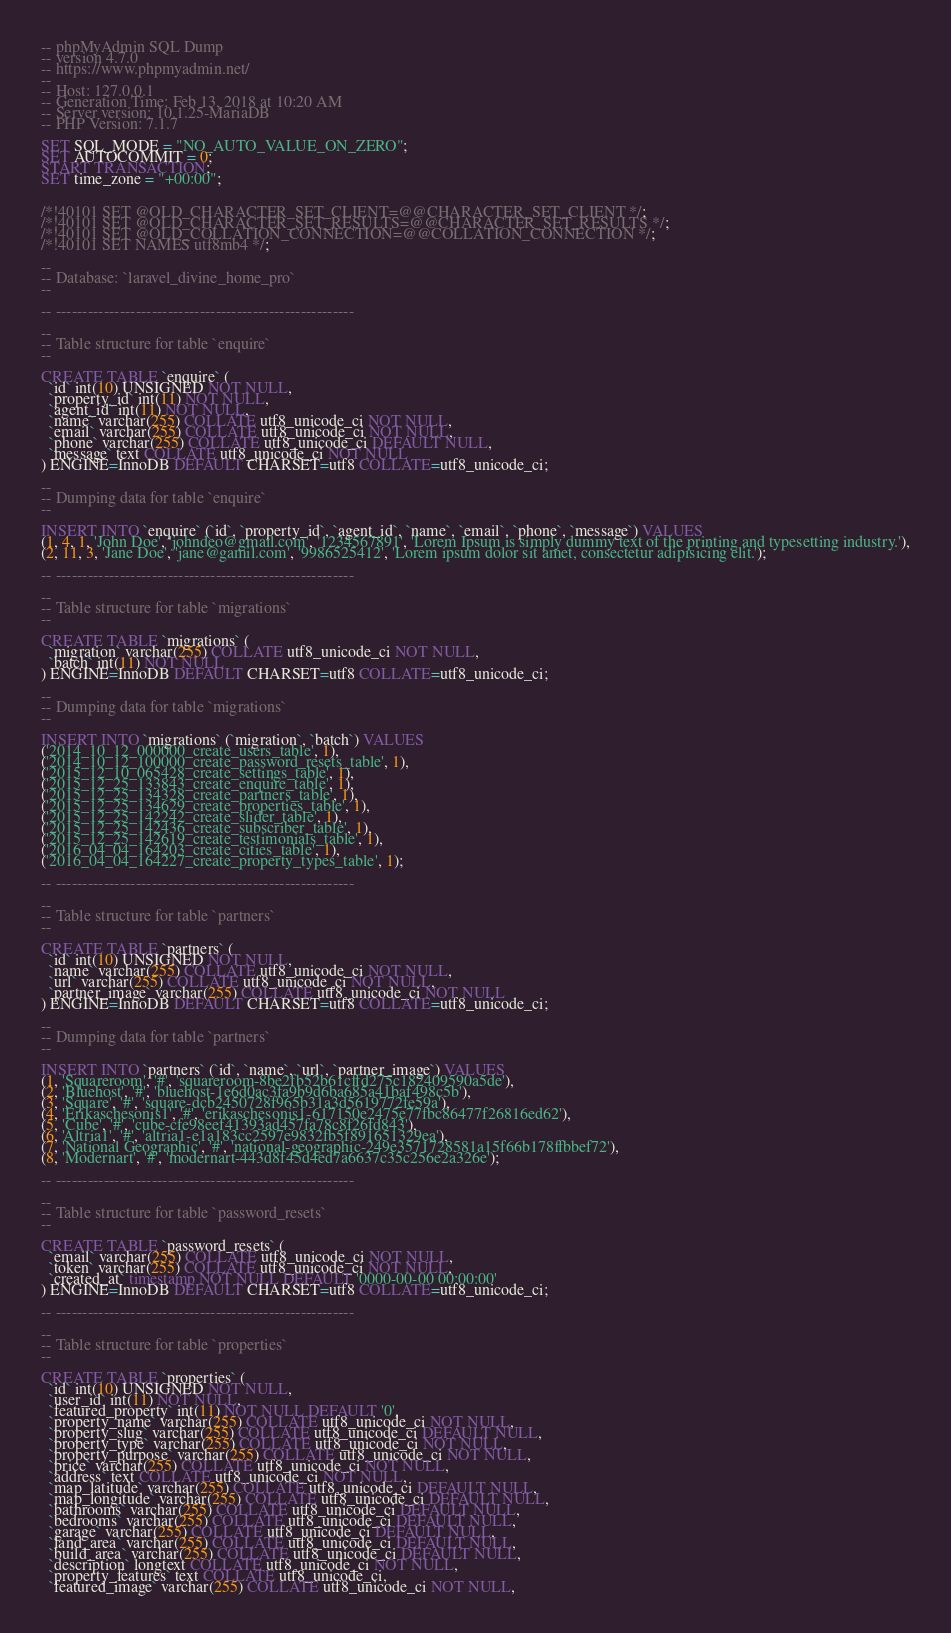<code> <loc_0><loc_0><loc_500><loc_500><_SQL_>-- phpMyAdmin SQL Dump
-- version 4.7.0
-- https://www.phpmyadmin.net/
--
-- Host: 127.0.0.1
-- Generation Time: Feb 13, 2018 at 10:20 AM
-- Server version: 10.1.25-MariaDB
-- PHP Version: 7.1.7

SET SQL_MODE = "NO_AUTO_VALUE_ON_ZERO";
SET AUTOCOMMIT = 0;
START TRANSACTION;
SET time_zone = "+00:00";


/*!40101 SET @OLD_CHARACTER_SET_CLIENT=@@CHARACTER_SET_CLIENT */;
/*!40101 SET @OLD_CHARACTER_SET_RESULTS=@@CHARACTER_SET_RESULTS */;
/*!40101 SET @OLD_COLLATION_CONNECTION=@@COLLATION_CONNECTION */;
/*!40101 SET NAMES utf8mb4 */;

--
-- Database: `laravel_divine_home_pro`
--

-- --------------------------------------------------------

--
-- Table structure for table `enquire`
--

CREATE TABLE `enquire` (
  `id` int(10) UNSIGNED NOT NULL,
  `property_id` int(11) NOT NULL,
  `agent_id` int(11) NOT NULL,
  `name` varchar(255) COLLATE utf8_unicode_ci NOT NULL,
  `email` varchar(255) COLLATE utf8_unicode_ci NOT NULL,
  `phone` varchar(255) COLLATE utf8_unicode_ci DEFAULT NULL,
  `message` text COLLATE utf8_unicode_ci NOT NULL
) ENGINE=InnoDB DEFAULT CHARSET=utf8 COLLATE=utf8_unicode_ci;

--
-- Dumping data for table `enquire`
--

INSERT INTO `enquire` (`id`, `property_id`, `agent_id`, `name`, `email`, `phone`, `message`) VALUES
(1, 4, 1, 'John Doe', 'johndeo@gmail.com', '1234567891', 'Lorem Ipsum is simply dummy text of the printing and typesetting industry.'),
(2, 11, 3, 'Jane Doe', 'jane@gamil.com', '9986525412', 'Lorem ipsum dolor sit amet, consectetur adipisicing elit.');

-- --------------------------------------------------------

--
-- Table structure for table `migrations`
--

CREATE TABLE `migrations` (
  `migration` varchar(255) COLLATE utf8_unicode_ci NOT NULL,
  `batch` int(11) NOT NULL
) ENGINE=InnoDB DEFAULT CHARSET=utf8 COLLATE=utf8_unicode_ci;

--
-- Dumping data for table `migrations`
--

INSERT INTO `migrations` (`migration`, `batch`) VALUES
('2014_10_12_000000_create_users_table', 1),
('2014_10_12_100000_create_password_resets_table', 1),
('2015_12_10_065428_create_settings_table', 1),
('2015_12_25_133843_create_enquire_table', 1),
('2015_12_25_134328_create_partners_table', 1),
('2015_12_25_134629_create_properties_table', 1),
('2015_12_25_142242_create_slider_table', 1),
('2015_12_25_142436_create_subscriber_table', 1),
('2015_12_25_142619_create_testimonials_table', 1),
('2016_04_04_164203_create_cities_table', 1),
('2016_04_04_164227_create_property_types_table', 1);

-- --------------------------------------------------------

--
-- Table structure for table `partners`
--

CREATE TABLE `partners` (
  `id` int(10) UNSIGNED NOT NULL,
  `name` varchar(255) COLLATE utf8_unicode_ci NOT NULL,
  `url` varchar(255) COLLATE utf8_unicode_ci NOT NULL,
  `partner_image` varchar(255) COLLATE utf8_unicode_ci NOT NULL
) ENGINE=InnoDB DEFAULT CHARSET=utf8 COLLATE=utf8_unicode_ci;

--
-- Dumping data for table `partners`
--

INSERT INTO `partners` (`id`, `name`, `url`, `partner_image`) VALUES
(1, 'Squareroom', '#', 'squareroom-8be2fb52b61cffd275c182409590a5de'),
(2, 'Bluehost', '#', 'bluehost-1e6d0ac3fa9b9d6ba685a41baf498c5b'),
(3, 'Square', '#', 'square-dcb2450728f965b31a3d5619772fe59a'),
(4, 'Erikaschesonis1', '#', 'erikaschesonis1-617150e2475e77fbc86477f26816ed62'),
(5, 'Cube', '#', 'cube-cfe98eef41393ad457fa78c8f26fd843'),
(6, 'Altria1', '#', 'altria1-e1a183cc2597e9832fb5f891651329ea'),
(7, 'National Geographic', '#', 'national-geographic-249e3571728581a15f66b178ffbbef72'),
(8, 'Modernart', '#', 'modernart-443d8f45d4ed7a6637c35c256e2a326e');

-- --------------------------------------------------------

--
-- Table structure for table `password_resets`
--

CREATE TABLE `password_resets` (
  `email` varchar(255) COLLATE utf8_unicode_ci NOT NULL,
  `token` varchar(255) COLLATE utf8_unicode_ci NOT NULL,
  `created_at` timestamp NOT NULL DEFAULT '0000-00-00 00:00:00'
) ENGINE=InnoDB DEFAULT CHARSET=utf8 COLLATE=utf8_unicode_ci;

-- --------------------------------------------------------

--
-- Table structure for table `properties`
--

CREATE TABLE `properties` (
  `id` int(10) UNSIGNED NOT NULL,
  `user_id` int(11) NOT NULL,
  `featured_property` int(11) NOT NULL DEFAULT '0',
  `property_name` varchar(255) COLLATE utf8_unicode_ci NOT NULL,
  `property_slug` varchar(255) COLLATE utf8_unicode_ci DEFAULT NULL,
  `property_type` varchar(255) COLLATE utf8_unicode_ci NOT NULL,
  `property_purpose` varchar(255) COLLATE utf8_unicode_ci NOT NULL,
  `price` varchar(255) COLLATE utf8_unicode_ci NOT NULL,
  `address` text COLLATE utf8_unicode_ci NOT NULL,
  `map_latitude` varchar(255) COLLATE utf8_unicode_ci DEFAULT NULL,
  `map_longitude` varchar(255) COLLATE utf8_unicode_ci DEFAULT NULL,
  `bathrooms` varchar(255) COLLATE utf8_unicode_ci DEFAULT NULL,
  `bedrooms` varchar(255) COLLATE utf8_unicode_ci DEFAULT NULL,
  `garage` varchar(255) COLLATE utf8_unicode_ci DEFAULT NULL,
  `land_area` varchar(255) COLLATE utf8_unicode_ci DEFAULT NULL,
  `build_area` varchar(255) COLLATE utf8_unicode_ci DEFAULT NULL,
  `description` longtext COLLATE utf8_unicode_ci NOT NULL,
  `property_features` text COLLATE utf8_unicode_ci,
  `featured_image` varchar(255) COLLATE utf8_unicode_ci NOT NULL,</code> 